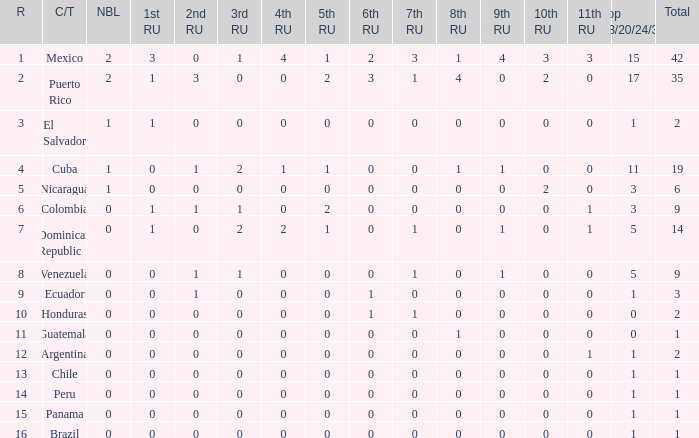Give me the full table as a dictionary. {'header': ['R', 'C/T', 'NBL', '1st RU', '2nd RU', '3rd RU', '4th RU', '5th RU', '6th RU', '7th RU', '8th RU', '9th RU', '10th RU', '11th RU', 'Top 18/20/24/30', 'Total'], 'rows': [['1', 'Mexico', '2', '3', '0', '1', '4', '1', '2', '3', '1', '4', '3', '3', '15', '42'], ['2', 'Puerto Rico', '2', '1', '3', '0', '0', '2', '3', '1', '4', '0', '2', '0', '17', '35'], ['3', 'El Salvador', '1', '1', '0', '0', '0', '0', '0', '0', '0', '0', '0', '0', '1', '2'], ['4', 'Cuba', '1', '0', '1', '2', '1', '1', '0', '0', '1', '1', '0', '0', '11', '19'], ['5', 'Nicaragua', '1', '0', '0', '0', '0', '0', '0', '0', '0', '0', '2', '0', '3', '6'], ['6', 'Colombia', '0', '1', '1', '1', '0', '2', '0', '0', '0', '0', '0', '1', '3', '9'], ['7', 'Dominican Republic', '0', '1', '0', '2', '2', '1', '0', '1', '0', '1', '0', '1', '5', '14'], ['8', 'Venezuela', '0', '0', '1', '1', '0', '0', '0', '1', '0', '1', '0', '0', '5', '9'], ['9', 'Ecuador', '0', '0', '1', '0', '0', '0', '1', '0', '0', '0', '0', '0', '1', '3'], ['10', 'Honduras', '0', '0', '0', '0', '0', '0', '1', '1', '0', '0', '0', '0', '0', '2'], ['11', 'Guatemala', '0', '0', '0', '0', '0', '0', '0', '0', '1', '0', '0', '0', '0', '1'], ['12', 'Argentina', '0', '0', '0', '0', '0', '0', '0', '0', '0', '0', '0', '1', '1', '2'], ['13', 'Chile', '0', '0', '0', '0', '0', '0', '0', '0', '0', '0', '0', '0', '1', '1'], ['14', 'Peru', '0', '0', '0', '0', '0', '0', '0', '0', '0', '0', '0', '0', '1', '1'], ['15', 'Panama', '0', '0', '0', '0', '0', '0', '0', '0', '0', '0', '0', '0', '1', '1'], ['16', 'Brazil', '0', '0', '0', '0', '0', '0', '0', '0', '0', '0', '0', '0', '1', '1']]} What is the total number of 3rd runners-up of the country ranked lower than 12 with a 10th runner-up of 0, an 8th runner-up less than 1, and a 7th runner-up of 0? 4.0. 